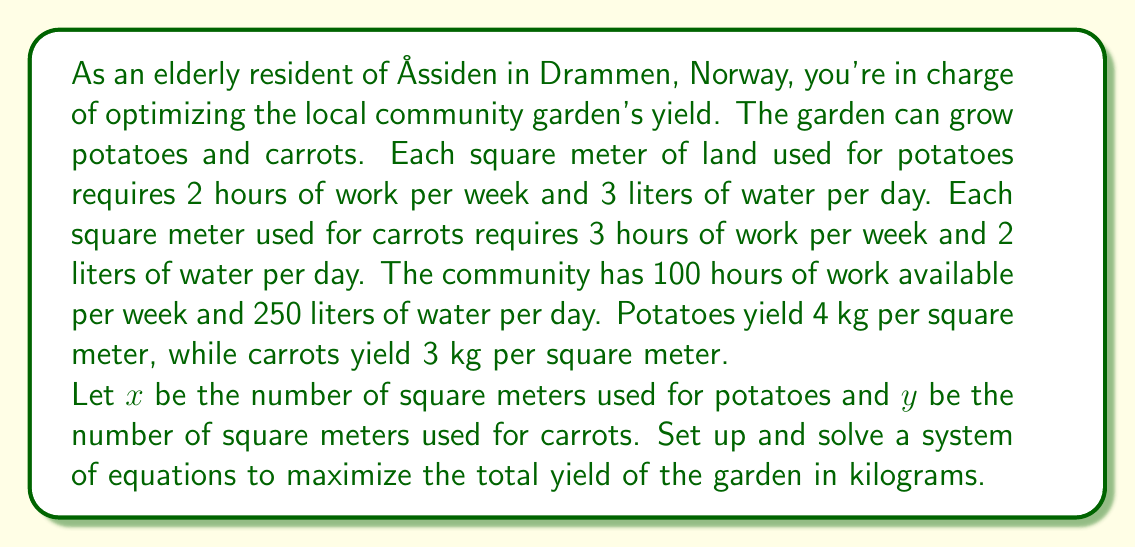Help me with this question. Let's approach this step-by-step:

1) First, we need to set up our constraints based on the available resources:

   Work constraint: $2x + 3y \leq 100$ (hours per week)
   Water constraint: $3x + 2y \leq 250$ (liters per day)

2) Our objective function (total yield in kg) is:

   $Z = 4x + 3y$ (kg)

3) We want to maximize Z subject to our constraints. This is a linear programming problem, which we can solve graphically or using the corner point method.

4) Let's find the corner points by solving the system of equations:

   $2x + 3y = 100$
   $3x + 2y = 250$

5) Multiply the first equation by 3 and the second by -2:

   $6x + 9y = 300$
   $-6x - 4y = -500$

6) Add these equations:

   $5y = -200$
   $y = -40$

7) This is not a valid solution as we can't have negative area. So, the optimal solution must lie on one of the axes or at the intersection of our constraint lines.

8) Let's find the intercepts:

   For $2x + 3y = 100$:
   x-intercept: $(50, 0)$
   y-intercept: $(0, \frac{100}{3})$

   For $3x + 2y = 250$:
   x-intercept: $(\frac{250}{3}, 0)$
   y-intercept: $(0, 125)$

9) The intersection point can be found by solving the original system:

   $2x + 3y = 100$
   $3x + 2y = 250$

   Solving this gives us: $(x, y) = (50, 0)$

10) Now, let's evaluate Z at each of these points:

    $(0, \frac{100}{3})$: $Z = 4(0) + 3(\frac{100}{3}) = 100$
    $(0, 125)$: $Z = 4(0) + 3(125) = 375$
    $(50, 0)$: $Z = 4(50) + 3(0) = 200$
    $(\frac{250}{3}, 0)$: $Z = 4(\frac{250}{3}) + 3(0) = \frac{1000}{3}$

11) The maximum value of Z occurs at $(0, 125)$, giving a yield of 375 kg.
Answer: The optimal solution is to use all 125 square meters for carrots and none for potatoes, resulting in a maximum yield of 375 kg. 